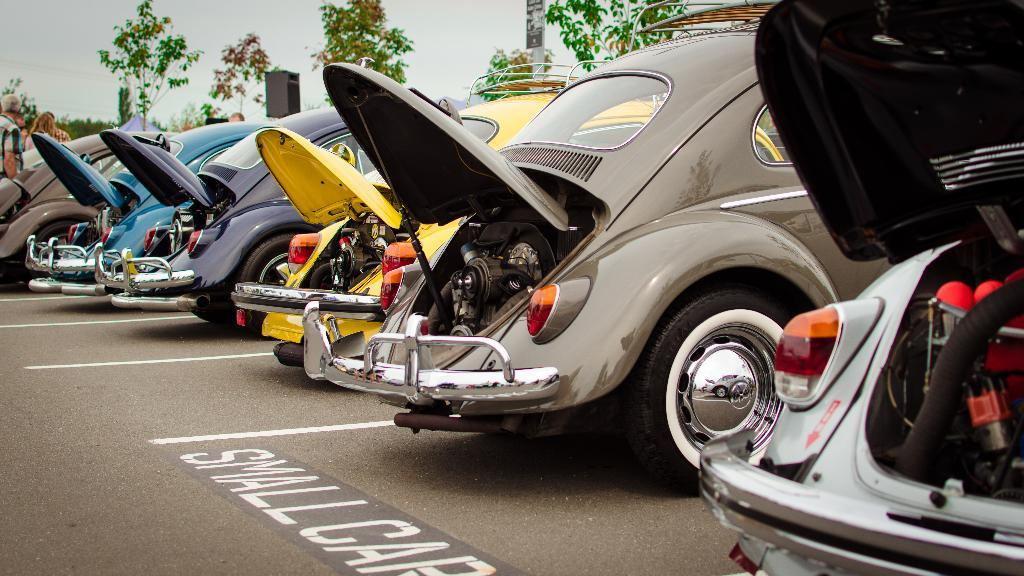What can be seen parked on the road in the image? There are motor vehicles parked on the road in the image. How are the motor vehicles arranged on the road? The motor vehicles are parked in a row. What can be seen in the background of the image? There are trees and the sky visible in the background of the image. What type of appliance can be seen plugged into the nail in the image? There is no appliance or nail present in the image. 